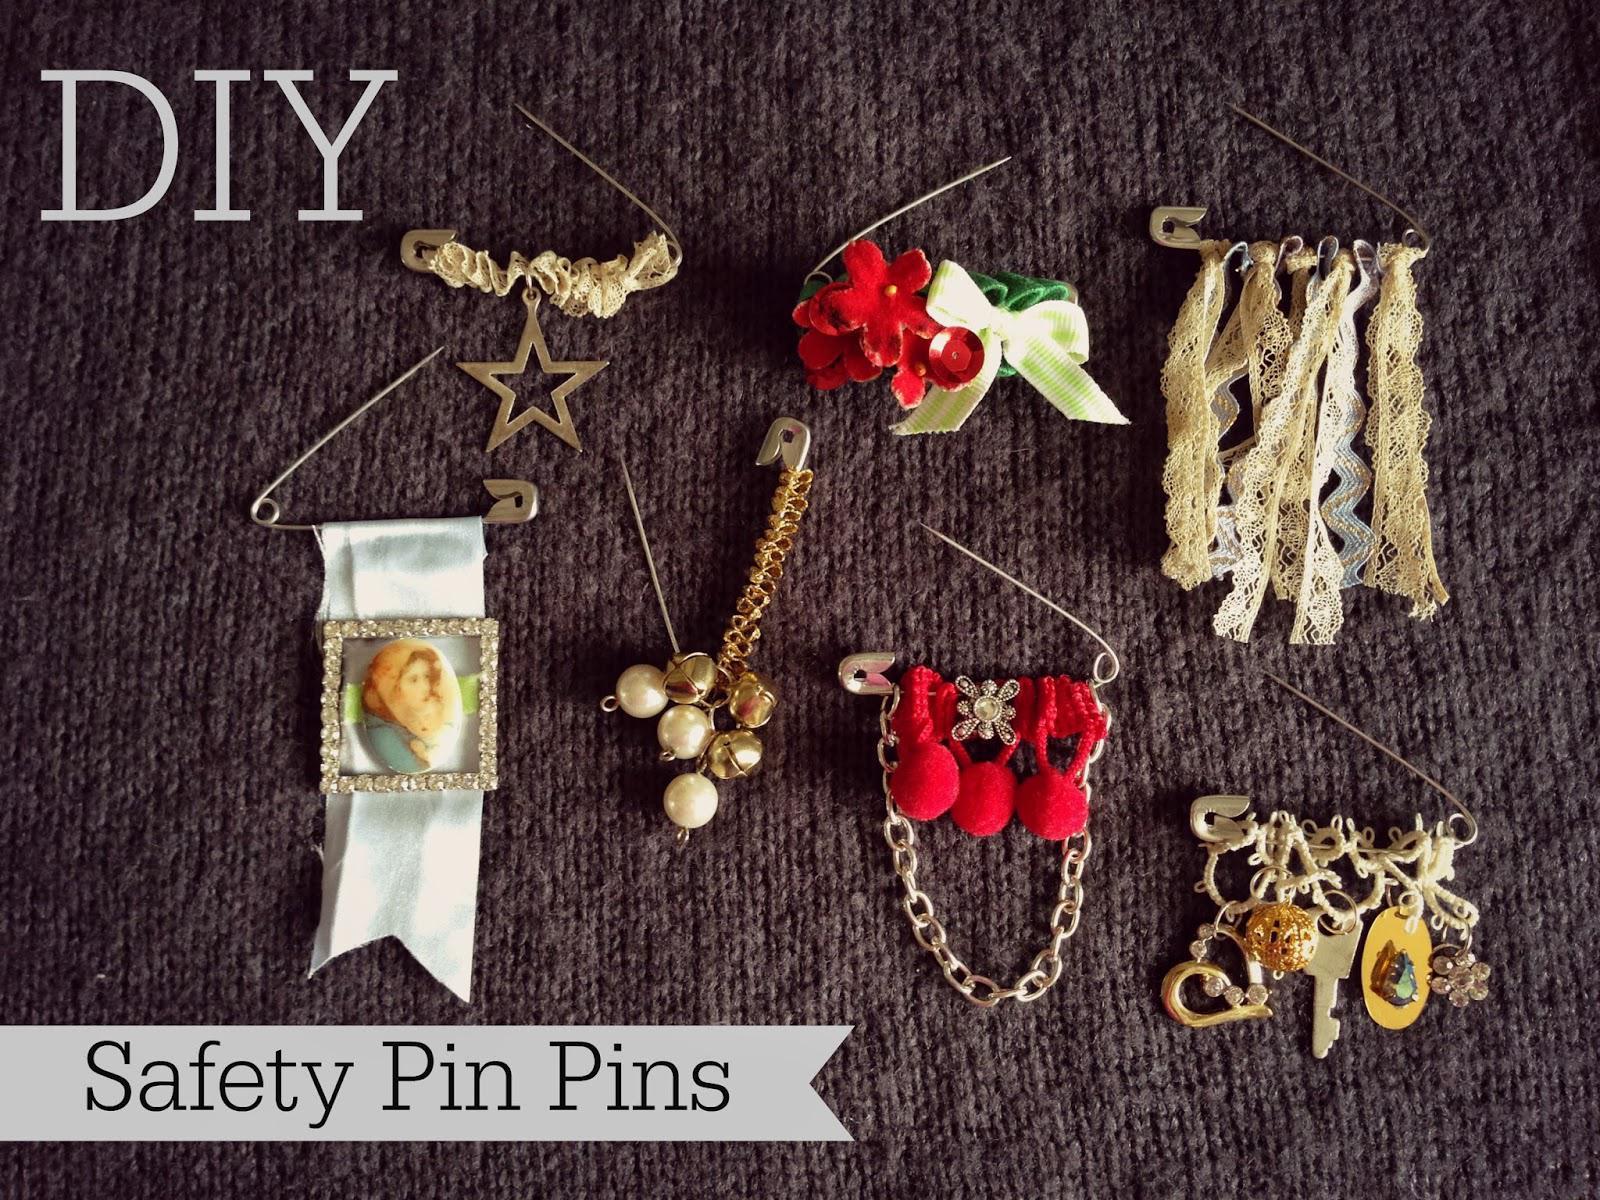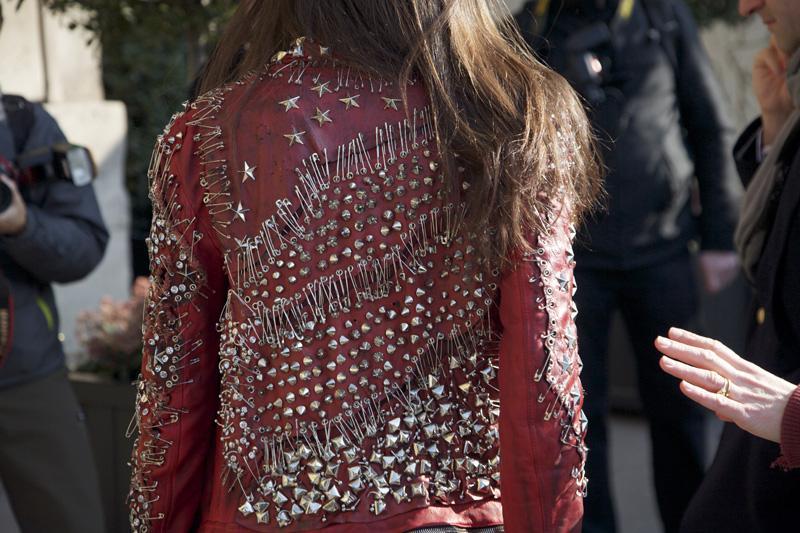The first image is the image on the left, the second image is the image on the right. Given the left and right images, does the statement "One image shows one bracelet made of beaded safety pins." hold true? Answer yes or no. No. The first image is the image on the left, the second image is the image on the right. Examine the images to the left and right. Is the description "There is a bracelet in the image on the left." accurate? Answer yes or no. No. 